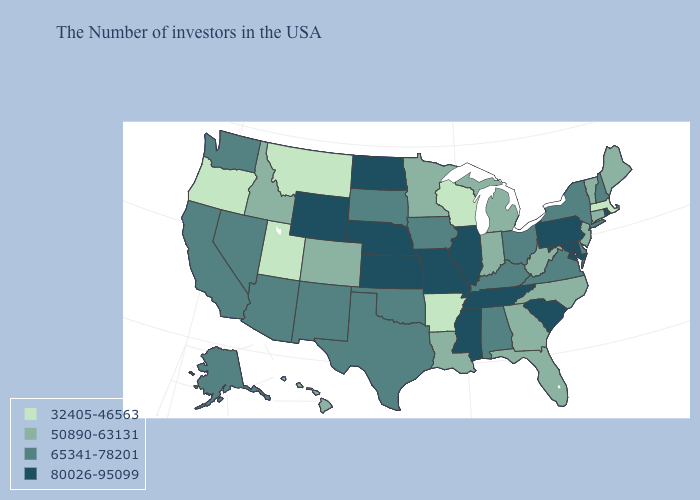What is the value of Kentucky?
Give a very brief answer. 65341-78201. What is the value of North Dakota?
Write a very short answer. 80026-95099. Does California have a higher value than North Dakota?
Concise answer only. No. Among the states that border Florida , does Georgia have the lowest value?
Short answer required. Yes. Which states hav the highest value in the South?
Concise answer only. Maryland, South Carolina, Tennessee, Mississippi. What is the highest value in the Northeast ?
Write a very short answer. 80026-95099. What is the value of Florida?
Give a very brief answer. 50890-63131. What is the highest value in states that border West Virginia?
Answer briefly. 80026-95099. What is the value of Wisconsin?
Short answer required. 32405-46563. Name the states that have a value in the range 65341-78201?
Be succinct. New Hampshire, New York, Delaware, Virginia, Ohio, Kentucky, Alabama, Iowa, Oklahoma, Texas, South Dakota, New Mexico, Arizona, Nevada, California, Washington, Alaska. What is the value of North Carolina?
Short answer required. 50890-63131. What is the highest value in states that border Arizona?
Write a very short answer. 65341-78201. Does Iowa have the lowest value in the USA?
Give a very brief answer. No. What is the highest value in the West ?
Concise answer only. 80026-95099. How many symbols are there in the legend?
Short answer required. 4. 